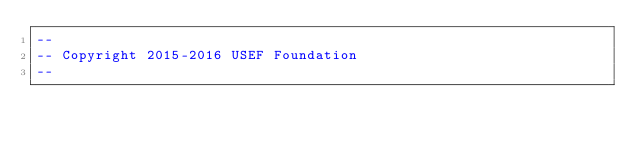<code> <loc_0><loc_0><loc_500><loc_500><_SQL_>--
-- Copyright 2015-2016 USEF Foundation
--</code> 